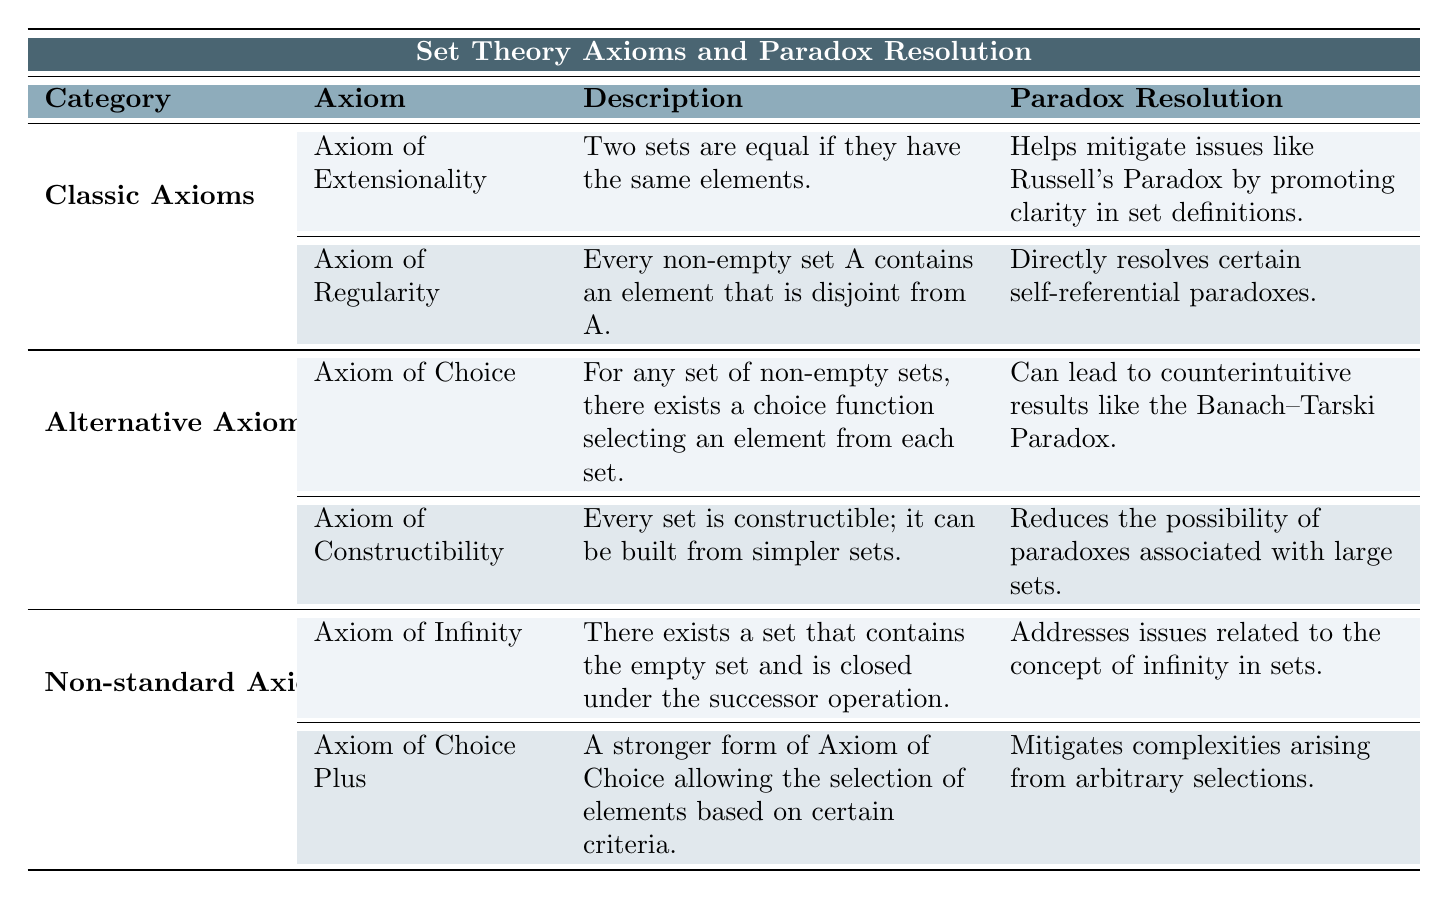What is the Description of the Axiom of Extensionality? The Description of the Axiom of Extensionality is explicitly provided in the table: "Two sets are equal if they have the same elements."
Answer: Two sets are equal if they have the same elements Which Axiom is associated with self-referential paradox resolution? According to the table, the Axiom of Regularity directly resolves certain self-referential paradoxes, as stated under the Paradox Resolution column.
Answer: Axiom of Regularity What are the implications of the Axiom of Choice? The table lists the implications of the Axiom of Choice as "Enables the construction of bases for vector spaces" and "Facilitates various mathematical arguments (e.g., Zorn's Lemma)."
Answer: Enables the construction of bases for vector spaces; Facilitates various mathematical arguments Does the Axiom of Constructibility resolve paradoxes associated with large sets? The table indicates that the Axiom of Constructibility reduces the possibility of paradoxes associated with large sets under the Paradox Resolution column, indicating a positive resolution.
Answer: Yes Which Axiom, in the Non-standard category, relates to the concept of infinity? By looking at the Non-standard Axioms in the table, the Axiom of Infinity is specifically stated to address issues related to the concept of infinity in sets.
Answer: Axiom of Infinity How many implications are listed for the Axiom of Regularity? The table shows that the Axiom of Regularity has two implications: "Avoids infinite descending membership chains" and "Establishes a foundation for the hierarchy in set theory." Therefore, there are two implications.
Answer: Two Which Axiom has a paradox resolution that includes counterintuitive results? The table reveals that the Axiom of Choice leads to counterintuitive results, specifically mentioning the Banach–Tarski Paradox in the associated Paradox Resolution field.
Answer: Axiom of Choice Compare the paradox resolutions of the Axiom of Extensionality and the Axiom of Choice. The Axiom of Extensionality resolves issues by promoting clarity in set definitions, addressing Russell's Paradox. In contrast, the Axiom of Choice can lead to counterintuitive results such as the Banach–Tarski Paradox, showing a divergence in their effects on paradoxes.
Answer: Axiom of Extensionality promotes clarity; Axiom of Choice can cause counterintuitive results What are the implications of the Axiom of Choice Plus? The implications of the Axiom of Choice Plus according to the table are "Provides a robust framework for advanced mathematical constructions" and "Allows for results in higher-dimensional spaces."
Answer: Provides a robust framework for advanced mathematical constructions; Allows for results in higher-dimensional spaces Identify and explain the main difference in paradox resolution between Classic Axioms and Non-standard Axioms. Classic Axioms like Extensionality and Regularity primarily mitigate existing paradoxes and clarify definitions, while Non-standard Axioms like Infinity and Choice Plus deal with foundational aspects of mathematics (like infinity concepts) and may introduce complexities, as seen in the paradoxes they can create.
Answer: Classic Axioms clarify and mitigate; Non-standard Axioms address foundations and may introduce complexities 